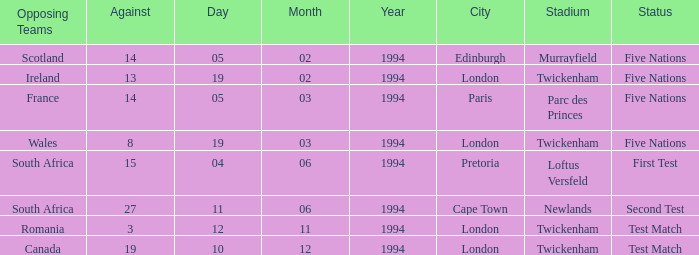Which venue has more than 19 against? Newlands , Cape Town. 